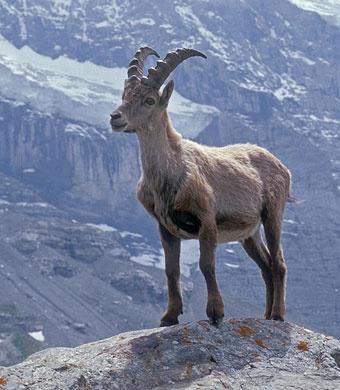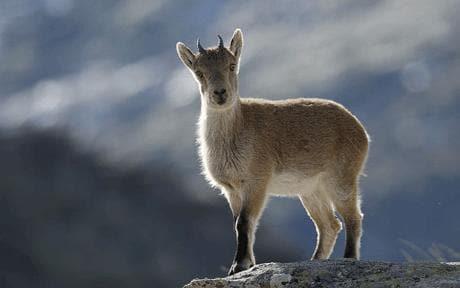The first image is the image on the left, the second image is the image on the right. Considering the images on both sides, is "The animal in the image on the left is clearly standing atop a peak." valid? Answer yes or no. Yes. 